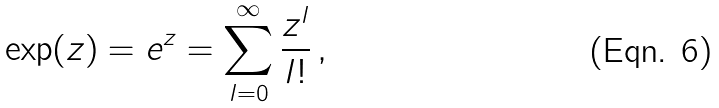<formula> <loc_0><loc_0><loc_500><loc_500>\exp ( z ) = e ^ { z } = \sum _ { l = 0 } ^ { \infty } \frac { z ^ { l } } { l ! } \, ,</formula> 